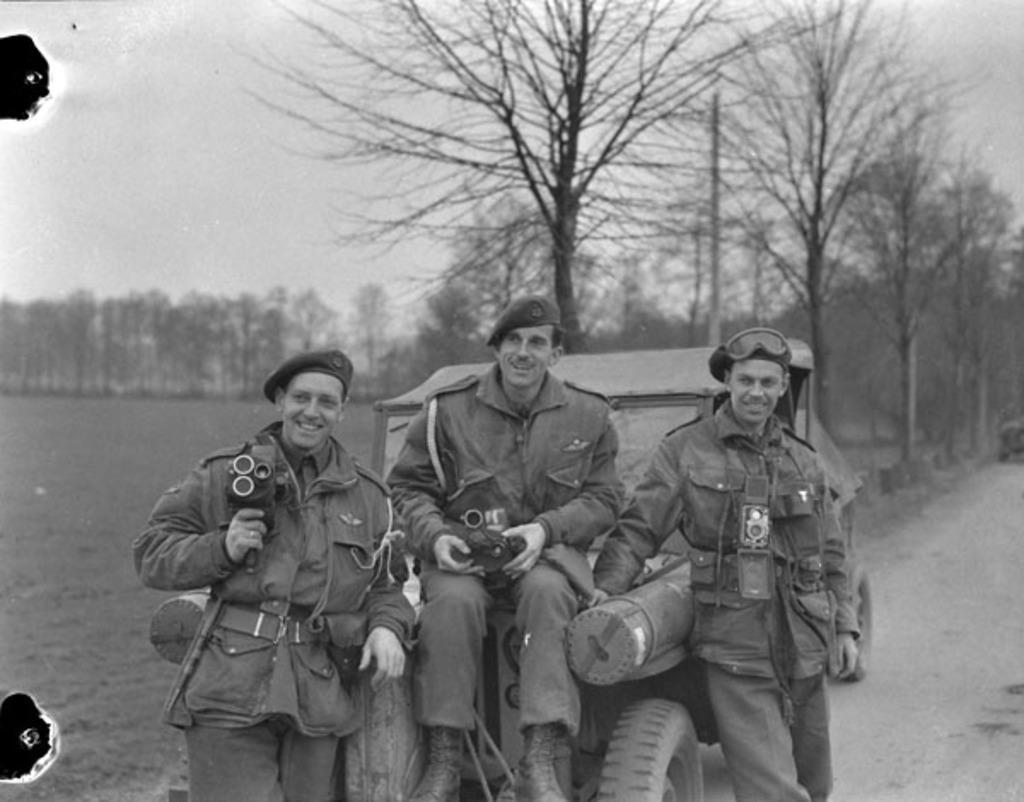Please provide a concise description of this image. This is a black and white image. I can see a man sitting on the jeep and smiling. There are two men standing and smiling. These are the trees. I can see two people holding the objects in their hands. 